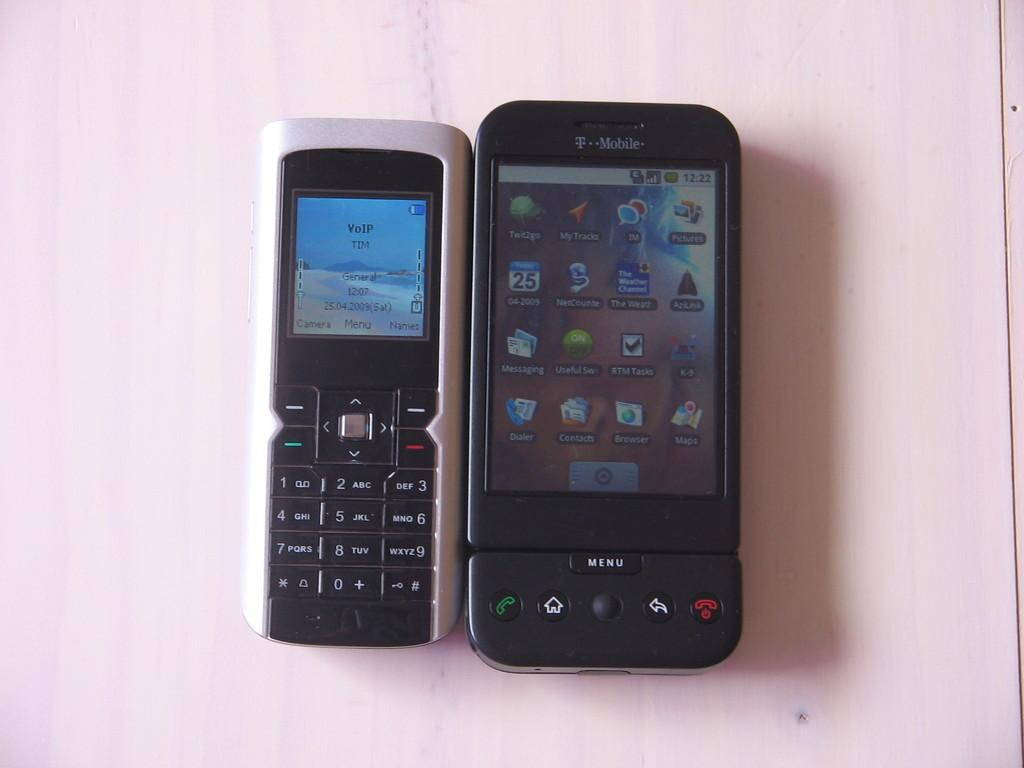<image>
Create a compact narrative representing the image presented. Two Smartphones with one of them labeled T Mobile and the other is VOIP TIM General 12:07. 